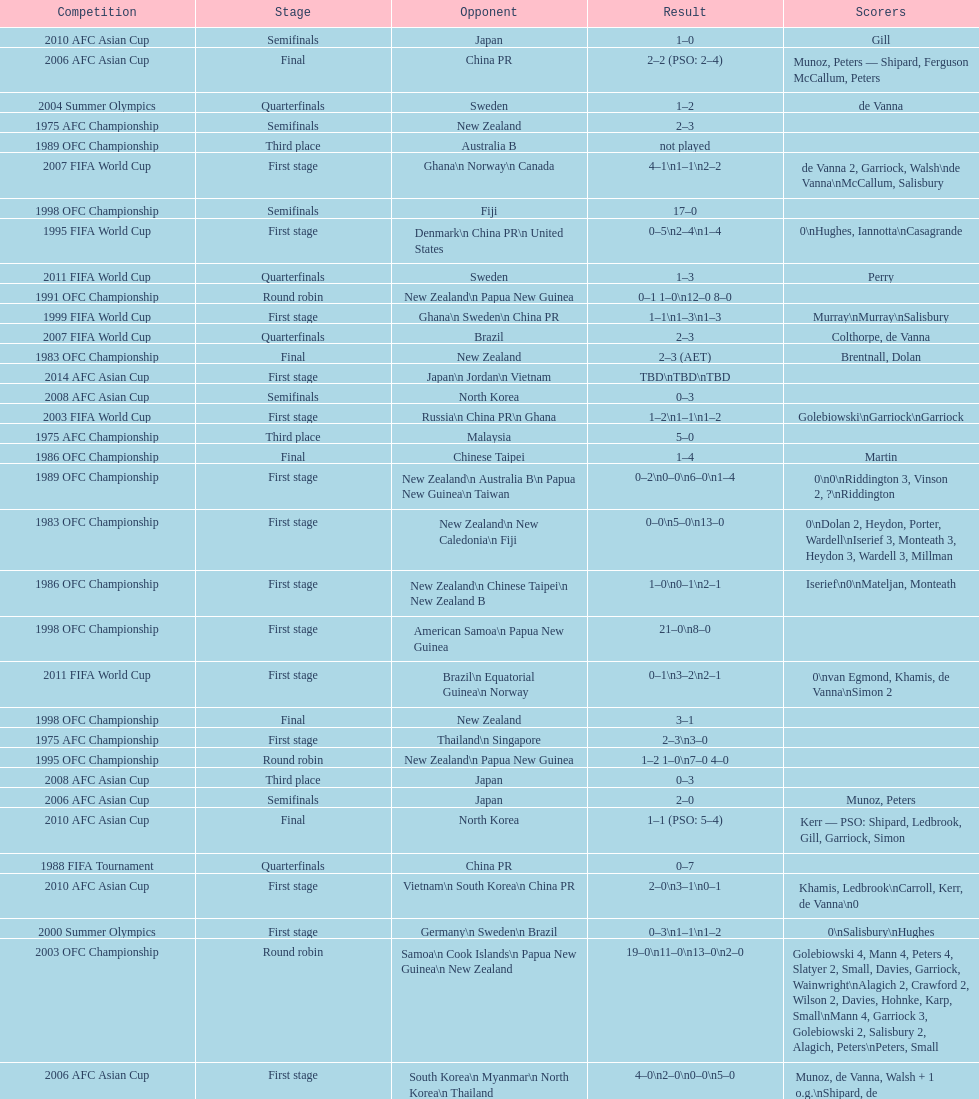Who scored better in the 1995 fifa world cup denmark or the united states? United States. 